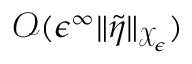<formula> <loc_0><loc_0><loc_500><loc_500>\mathcal { O } ( \epsilon ^ { \infty } \| \tilde { \eta } \| _ { \mathcal { X } _ { \epsilon } } )</formula> 